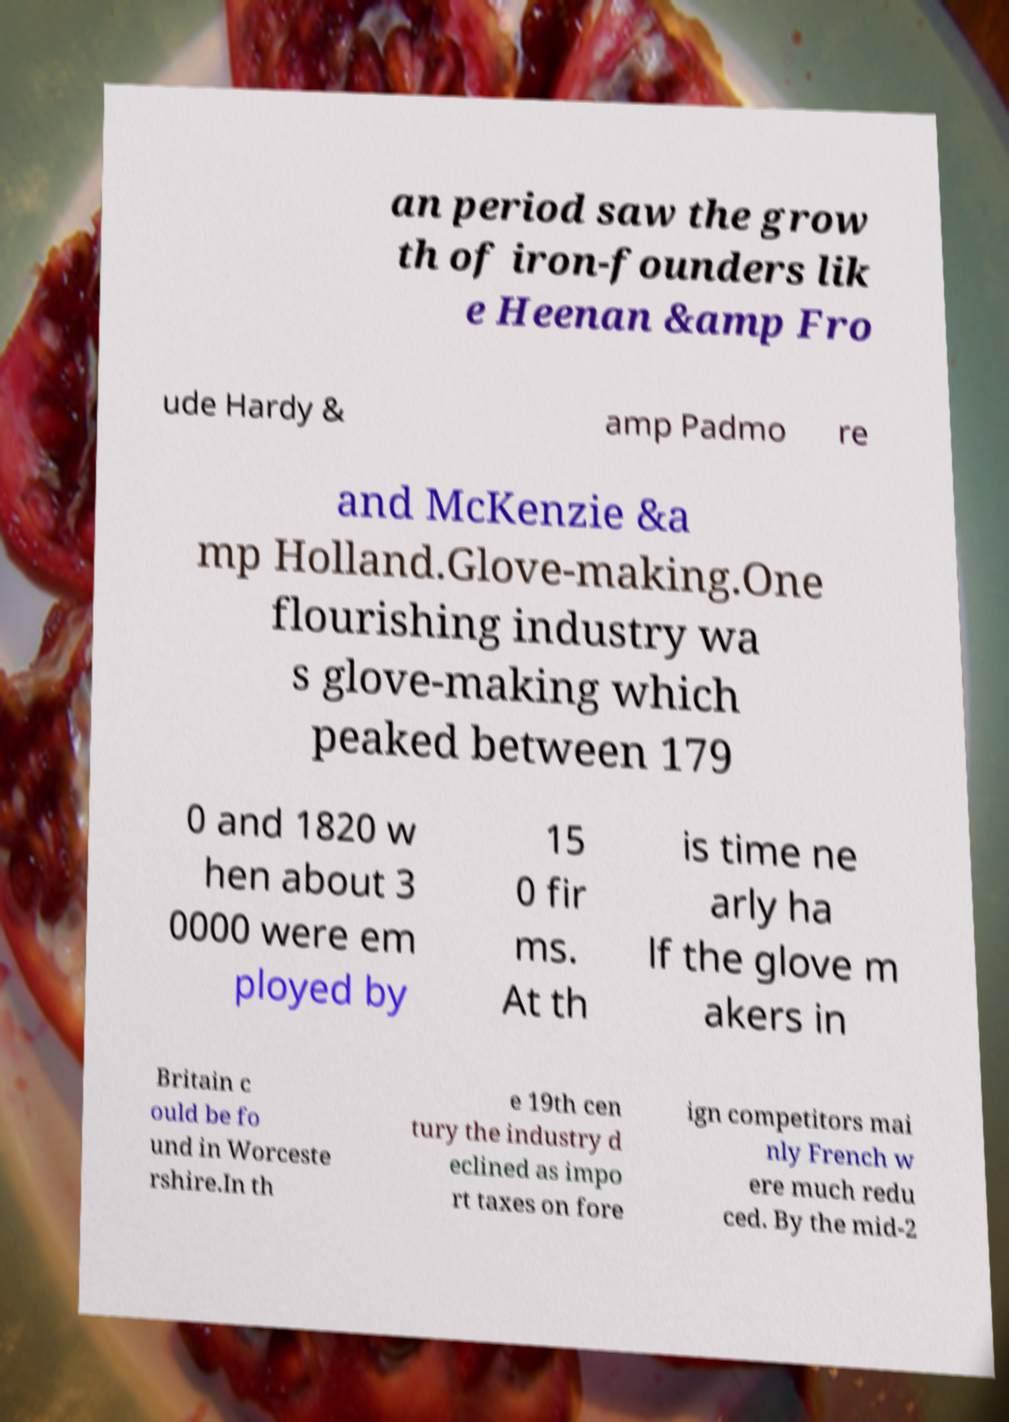I need the written content from this picture converted into text. Can you do that? an period saw the grow th of iron-founders lik e Heenan &amp Fro ude Hardy & amp Padmo re and McKenzie &a mp Holland.Glove-making.One flourishing industry wa s glove-making which peaked between 179 0 and 1820 w hen about 3 0000 were em ployed by 15 0 fir ms. At th is time ne arly ha lf the glove m akers in Britain c ould be fo und in Worceste rshire.In th e 19th cen tury the industry d eclined as impo rt taxes on fore ign competitors mai nly French w ere much redu ced. By the mid-2 